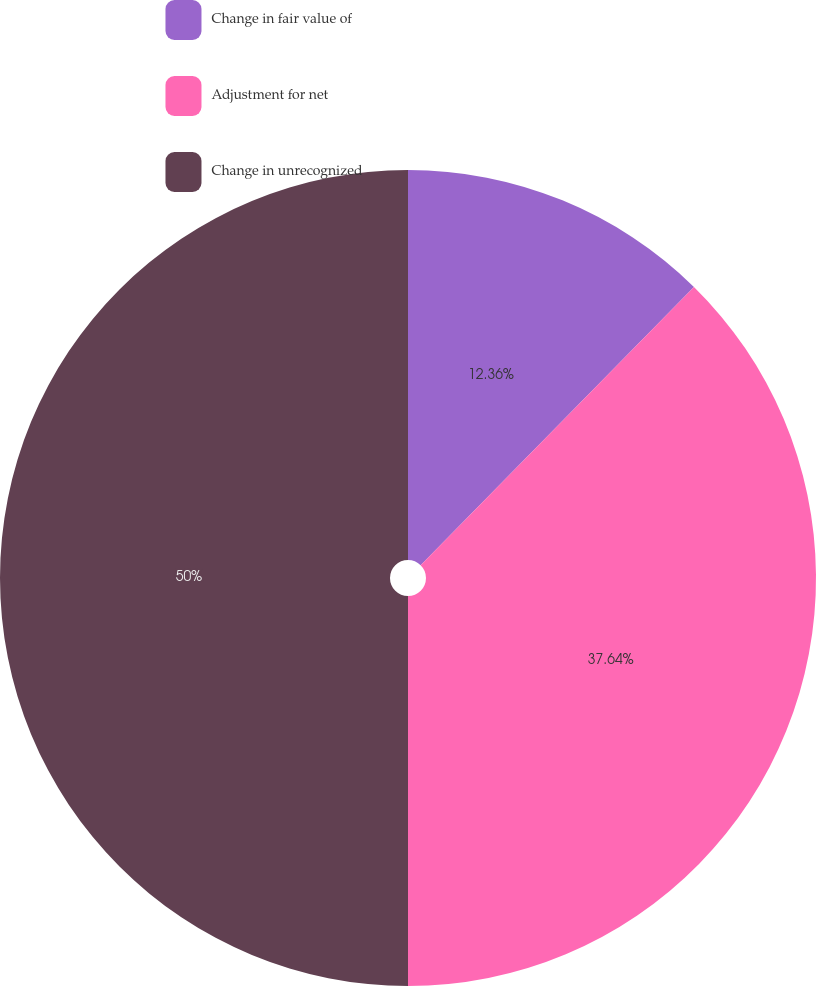Convert chart to OTSL. <chart><loc_0><loc_0><loc_500><loc_500><pie_chart><fcel>Change in fair value of<fcel>Adjustment for net<fcel>Change in unrecognized<nl><fcel>12.36%<fcel>37.64%<fcel>50.0%<nl></chart> 